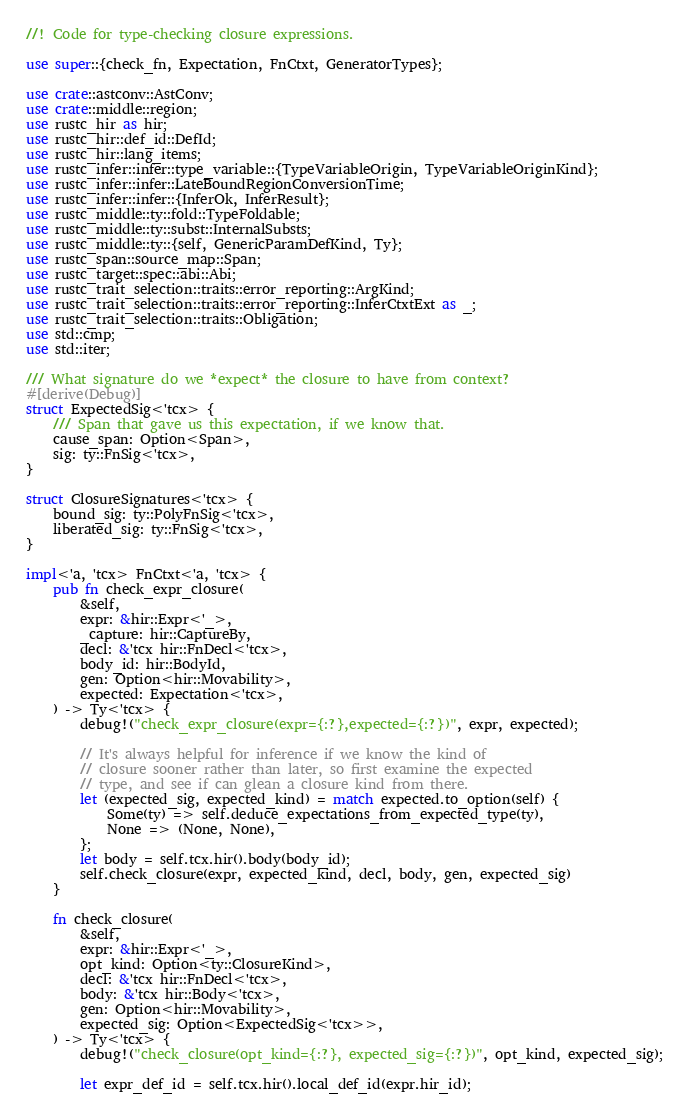Convert code to text. <code><loc_0><loc_0><loc_500><loc_500><_Rust_>//! Code for type-checking closure expressions.

use super::{check_fn, Expectation, FnCtxt, GeneratorTypes};

use crate::astconv::AstConv;
use crate::middle::region;
use rustc_hir as hir;
use rustc_hir::def_id::DefId;
use rustc_hir::lang_items;
use rustc_infer::infer::type_variable::{TypeVariableOrigin, TypeVariableOriginKind};
use rustc_infer::infer::LateBoundRegionConversionTime;
use rustc_infer::infer::{InferOk, InferResult};
use rustc_middle::ty::fold::TypeFoldable;
use rustc_middle::ty::subst::InternalSubsts;
use rustc_middle::ty::{self, GenericParamDefKind, Ty};
use rustc_span::source_map::Span;
use rustc_target::spec::abi::Abi;
use rustc_trait_selection::traits::error_reporting::ArgKind;
use rustc_trait_selection::traits::error_reporting::InferCtxtExt as _;
use rustc_trait_selection::traits::Obligation;
use std::cmp;
use std::iter;

/// What signature do we *expect* the closure to have from context?
#[derive(Debug)]
struct ExpectedSig<'tcx> {
    /// Span that gave us this expectation, if we know that.
    cause_span: Option<Span>,
    sig: ty::FnSig<'tcx>,
}

struct ClosureSignatures<'tcx> {
    bound_sig: ty::PolyFnSig<'tcx>,
    liberated_sig: ty::FnSig<'tcx>,
}

impl<'a, 'tcx> FnCtxt<'a, 'tcx> {
    pub fn check_expr_closure(
        &self,
        expr: &hir::Expr<'_>,
        _capture: hir::CaptureBy,
        decl: &'tcx hir::FnDecl<'tcx>,
        body_id: hir::BodyId,
        gen: Option<hir::Movability>,
        expected: Expectation<'tcx>,
    ) -> Ty<'tcx> {
        debug!("check_expr_closure(expr={:?},expected={:?})", expr, expected);

        // It's always helpful for inference if we know the kind of
        // closure sooner rather than later, so first examine the expected
        // type, and see if can glean a closure kind from there.
        let (expected_sig, expected_kind) = match expected.to_option(self) {
            Some(ty) => self.deduce_expectations_from_expected_type(ty),
            None => (None, None),
        };
        let body = self.tcx.hir().body(body_id);
        self.check_closure(expr, expected_kind, decl, body, gen, expected_sig)
    }

    fn check_closure(
        &self,
        expr: &hir::Expr<'_>,
        opt_kind: Option<ty::ClosureKind>,
        decl: &'tcx hir::FnDecl<'tcx>,
        body: &'tcx hir::Body<'tcx>,
        gen: Option<hir::Movability>,
        expected_sig: Option<ExpectedSig<'tcx>>,
    ) -> Ty<'tcx> {
        debug!("check_closure(opt_kind={:?}, expected_sig={:?})", opt_kind, expected_sig);

        let expr_def_id = self.tcx.hir().local_def_id(expr.hir_id);
</code> 